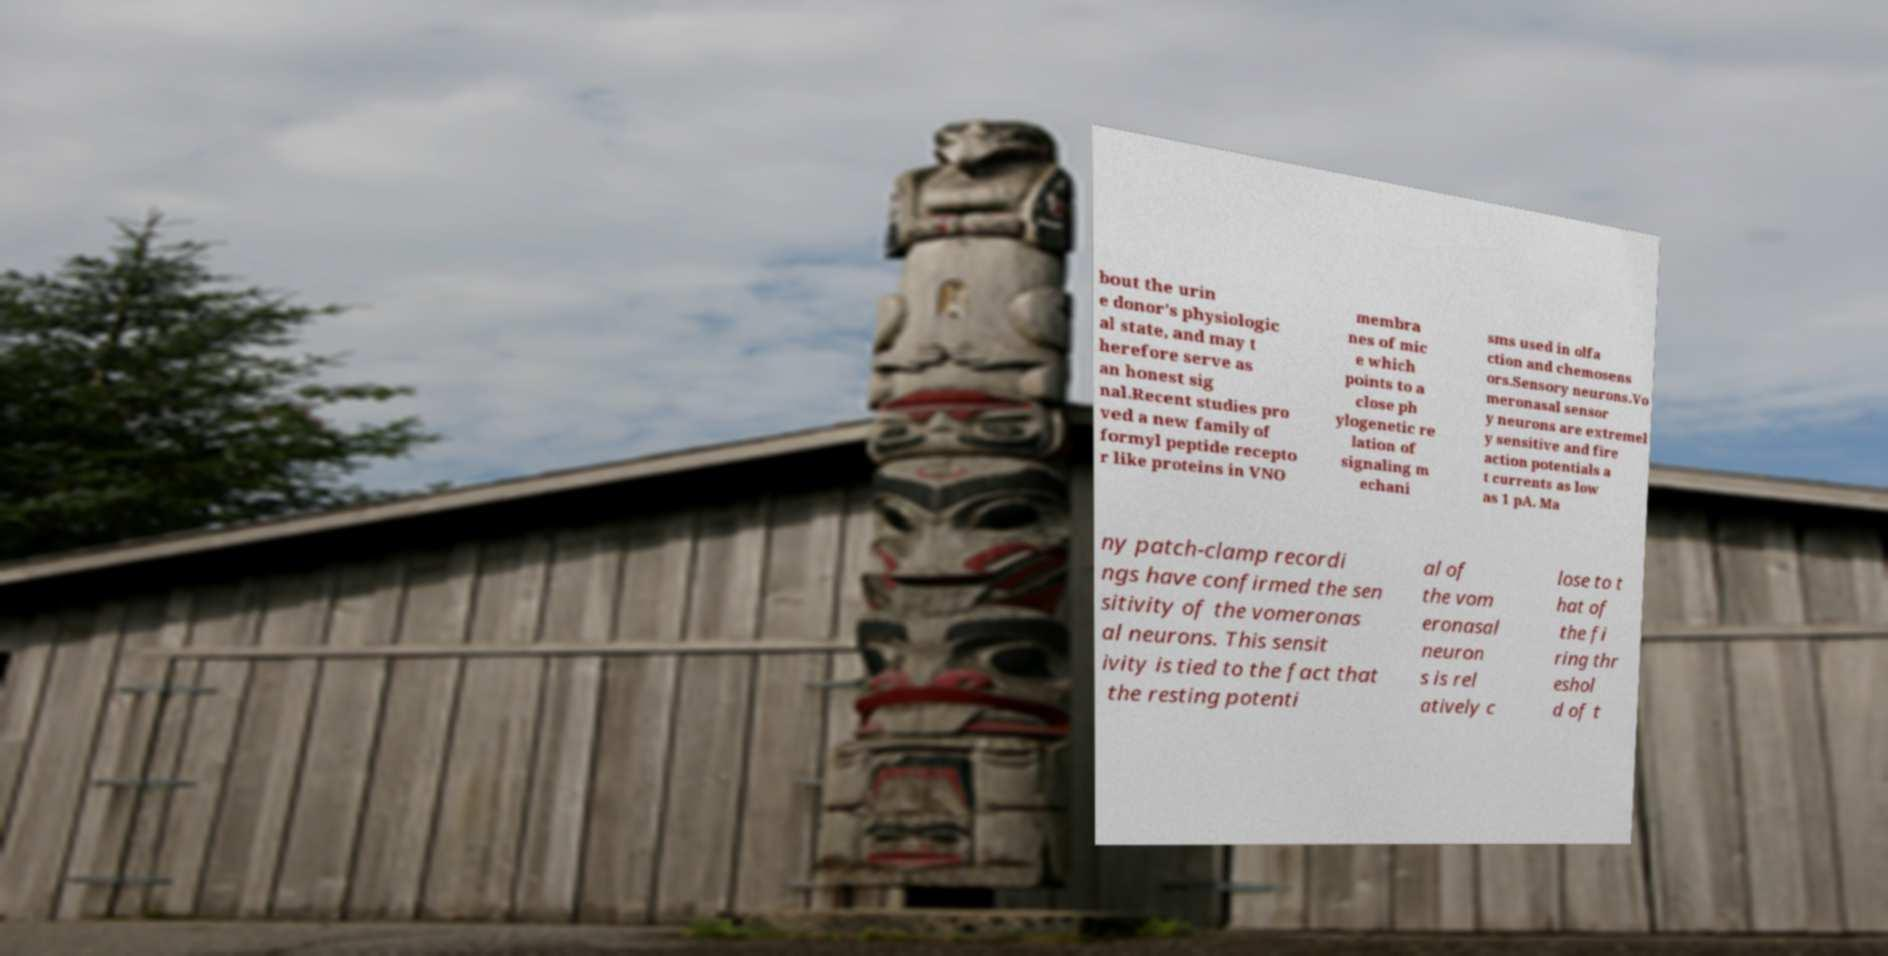Please read and relay the text visible in this image. What does it say? bout the urin e donor's physiologic al state, and may t herefore serve as an honest sig nal.Recent studies pro ved a new family of formyl peptide recepto r like proteins in VNO membra nes of mic e which points to a close ph ylogenetic re lation of signaling m echani sms used in olfa ction and chemosens ors.Sensory neurons.Vo meronasal sensor y neurons are extremel y sensitive and fire action potentials a t currents as low as 1 pA. Ma ny patch-clamp recordi ngs have confirmed the sen sitivity of the vomeronas al neurons. This sensit ivity is tied to the fact that the resting potenti al of the vom eronasal neuron s is rel atively c lose to t hat of the fi ring thr eshol d of t 